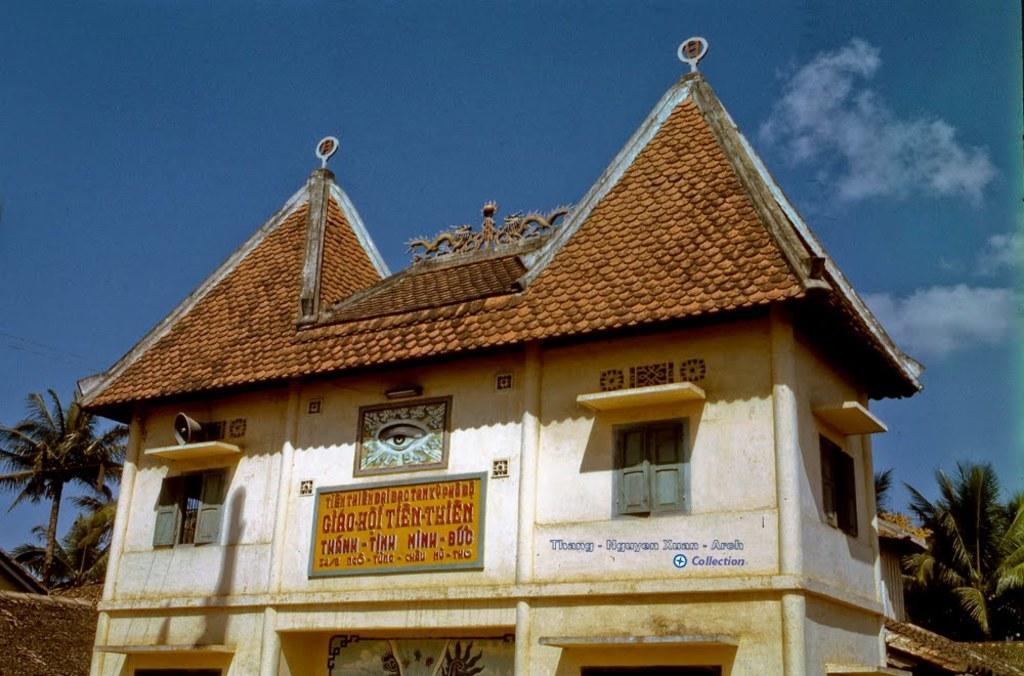Could you give a brief overview of what you see in this image? This picture is taken from outside of the city. In this image, on the right side, we can see some trees. On the left side, we can also see some trees and a roof of a house. In the middle of the image, we can see a building, the board, in, the board, we can see some text written on it, window, roof. At the top, we can see a sky which is a bit cloudy. 